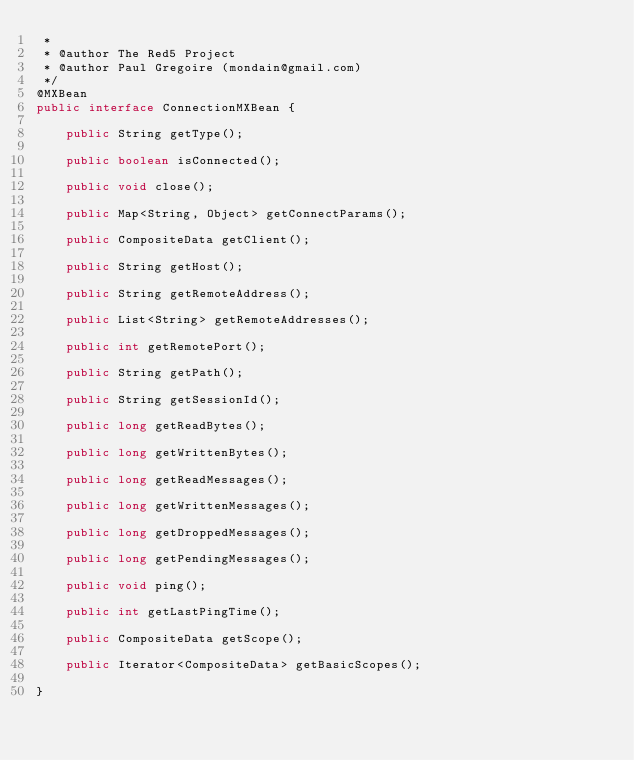<code> <loc_0><loc_0><loc_500><loc_500><_Java_> *
 * @author The Red5 Project
 * @author Paul Gregoire (mondain@gmail.com)
 */
@MXBean
public interface ConnectionMXBean {

    public String getType();

    public boolean isConnected();

    public void close();

    public Map<String, Object> getConnectParams();

    public CompositeData getClient();

    public String getHost();

    public String getRemoteAddress();

    public List<String> getRemoteAddresses();

    public int getRemotePort();

    public String getPath();

    public String getSessionId();

    public long getReadBytes();

    public long getWrittenBytes();

    public long getReadMessages();

    public long getWrittenMessages();

    public long getDroppedMessages();

    public long getPendingMessages();

    public void ping();

    public int getLastPingTime();

    public CompositeData getScope();

    public Iterator<CompositeData> getBasicScopes();

}
</code> 